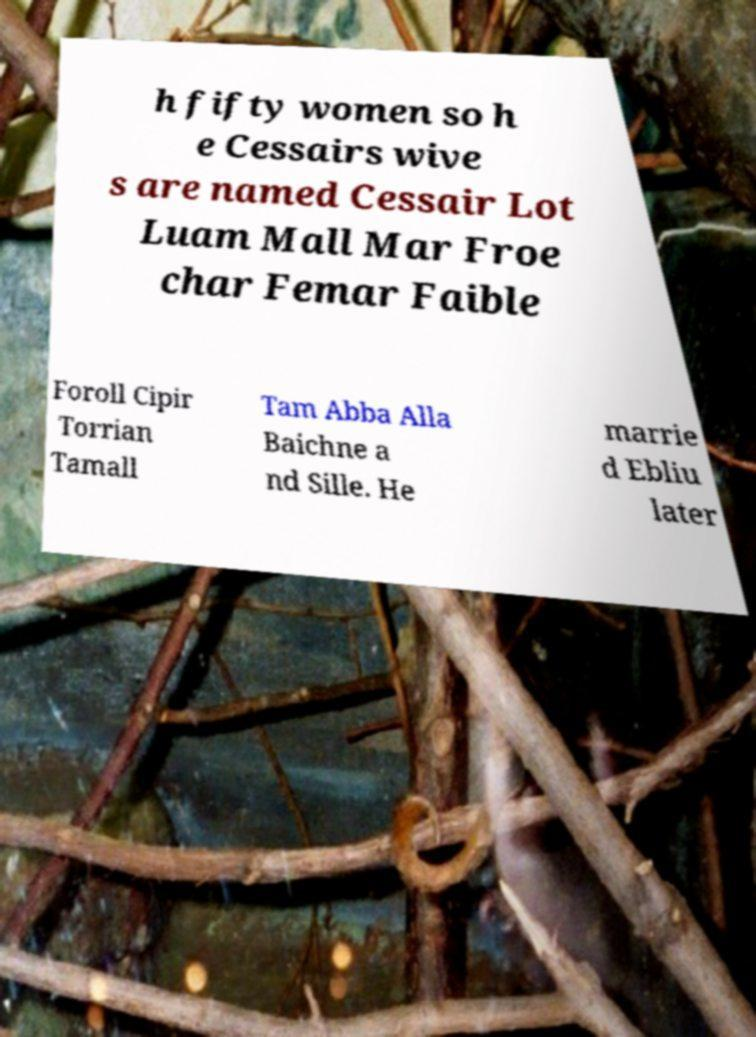Please identify and transcribe the text found in this image. h fifty women so h e Cessairs wive s are named Cessair Lot Luam Mall Mar Froe char Femar Faible Foroll Cipir Torrian Tamall Tam Abba Alla Baichne a nd Sille. He marrie d Ebliu later 